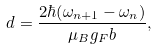Convert formula to latex. <formula><loc_0><loc_0><loc_500><loc_500>d = \frac { 2 \hbar { ( } \omega _ { n + 1 } - \omega _ { n } ) } { \mu _ { B } g _ { F } b } ,</formula> 